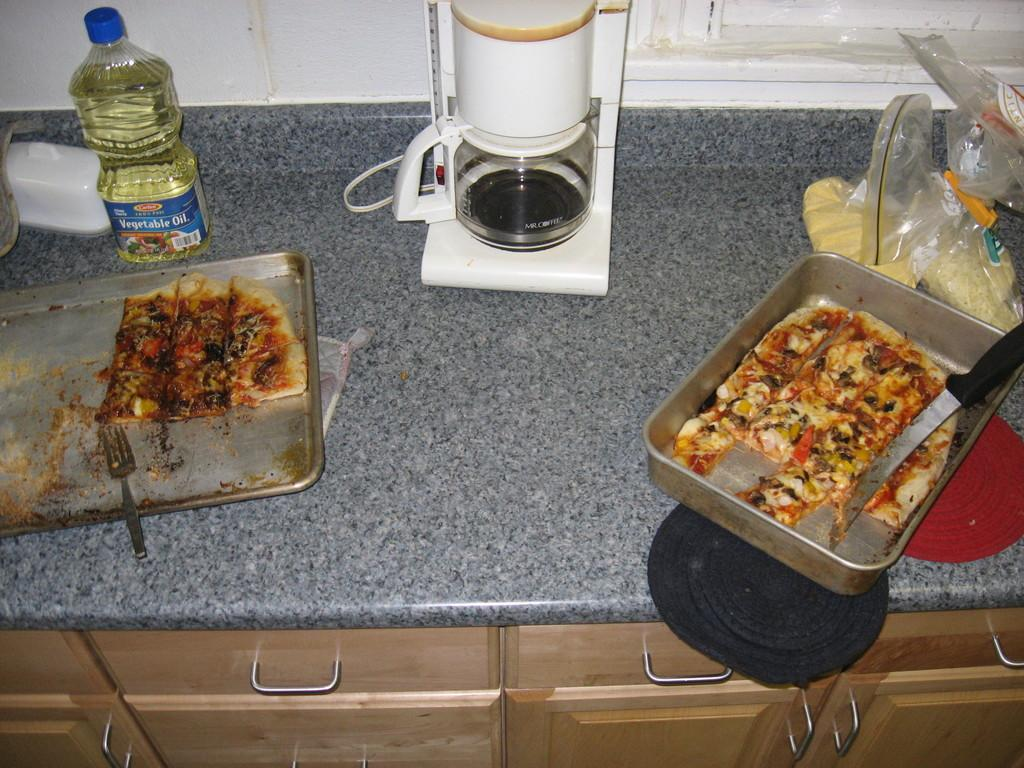<image>
Summarize the visual content of the image. some pizza next to a bottle of vegetable oil 